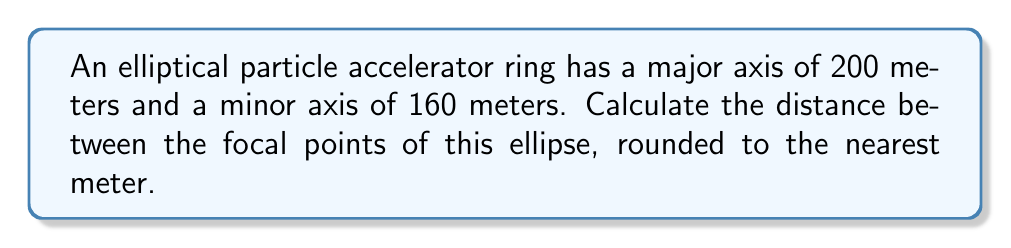Solve this math problem. Let's approach this step-by-step:

1) In an ellipse, we define:
   $a$ = semi-major axis
   $b$ = semi-minor axis
   $c$ = distance from center to focal point

2) We're given the full lengths of the axes, so:
   $a = 100$ meters (half of 200)
   $b = 80$ meters (half of 160)

3) The relationship between $a$, $b$, and $c$ in an ellipse is:
   $$a^2 = b^2 + c^2$$

4) We can rearrange this to solve for $c$:
   $$c^2 = a^2 - b^2$$
   $$c = \sqrt{a^2 - b^2}$$

5) Substituting our values:
   $$c = \sqrt{100^2 - 80^2}$$
   $$c = \sqrt{10000 - 6400}$$
   $$c = \sqrt{3600}$$
   $$c = 60$$

6) This is the distance from the center to one focal point. The distance between the two focal points is twice this:
   $$2c = 2 * 60 = 120$$ meters

Therefore, the distance between the focal points is 120 meters.

[asy]
unitsize(0.03cm);
draw(ellipse((0,0),100,80));
draw((-100,0)--(100,0));
draw((0,-80)--(0,80));
dot((-60,0));
dot((60,0));
label("F1", (-60,-5), S);
label("F2", (60,-5), S);
label("2c = 120m", (0,-5), N);
[/asy]
Answer: 120 meters 